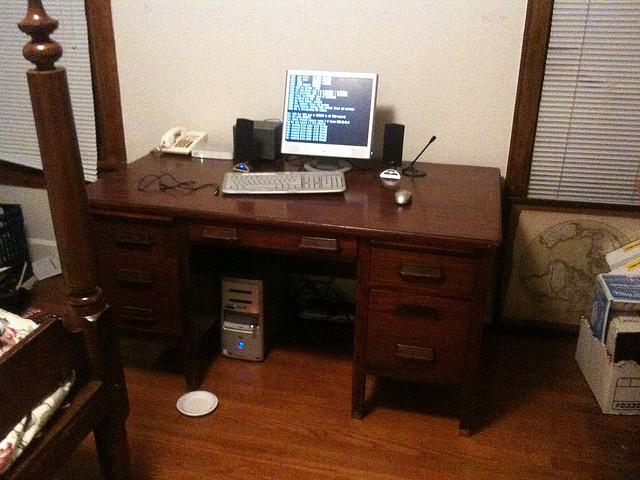How many phones are in this photo?
Short answer required. 1. Is this a new computer?
Answer briefly. No. What is on the floor?
Keep it brief. Plate. 